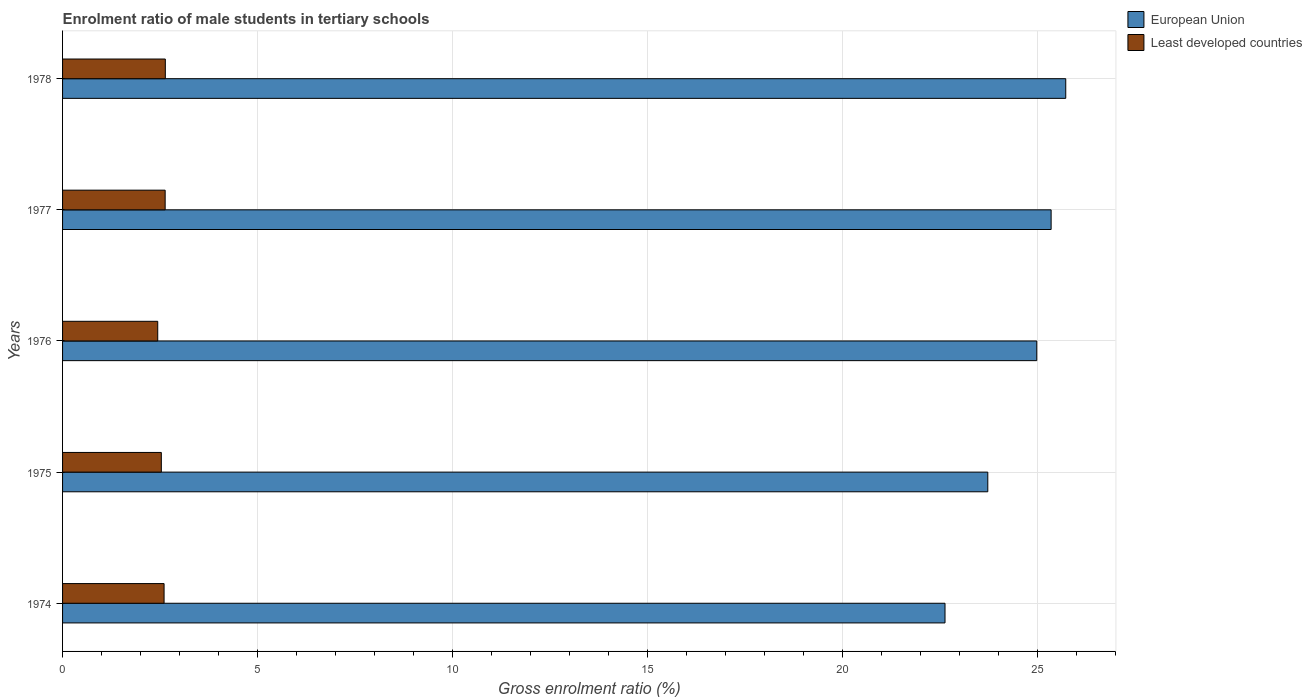How many different coloured bars are there?
Your answer should be very brief. 2. How many groups of bars are there?
Your answer should be very brief. 5. Are the number of bars on each tick of the Y-axis equal?
Make the answer very short. Yes. How many bars are there on the 1st tick from the bottom?
Your answer should be compact. 2. What is the label of the 3rd group of bars from the top?
Your answer should be compact. 1976. In how many cases, is the number of bars for a given year not equal to the number of legend labels?
Offer a terse response. 0. What is the enrolment ratio of male students in tertiary schools in Least developed countries in 1978?
Give a very brief answer. 2.63. Across all years, what is the maximum enrolment ratio of male students in tertiary schools in European Union?
Your answer should be compact. 25.72. Across all years, what is the minimum enrolment ratio of male students in tertiary schools in European Union?
Provide a succinct answer. 22.63. In which year was the enrolment ratio of male students in tertiary schools in Least developed countries maximum?
Your answer should be compact. 1978. In which year was the enrolment ratio of male students in tertiary schools in European Union minimum?
Keep it short and to the point. 1974. What is the total enrolment ratio of male students in tertiary schools in European Union in the graph?
Your answer should be compact. 122.4. What is the difference between the enrolment ratio of male students in tertiary schools in Least developed countries in 1977 and that in 1978?
Provide a short and direct response. -0. What is the difference between the enrolment ratio of male students in tertiary schools in European Union in 1975 and the enrolment ratio of male students in tertiary schools in Least developed countries in 1974?
Make the answer very short. 21.12. What is the average enrolment ratio of male students in tertiary schools in European Union per year?
Ensure brevity in your answer.  24.48. In the year 1978, what is the difference between the enrolment ratio of male students in tertiary schools in European Union and enrolment ratio of male students in tertiary schools in Least developed countries?
Your answer should be very brief. 23.09. What is the ratio of the enrolment ratio of male students in tertiary schools in European Union in 1974 to that in 1978?
Ensure brevity in your answer.  0.88. Is the enrolment ratio of male students in tertiary schools in Least developed countries in 1977 less than that in 1978?
Offer a terse response. Yes. What is the difference between the highest and the second highest enrolment ratio of male students in tertiary schools in Least developed countries?
Ensure brevity in your answer.  0. What is the difference between the highest and the lowest enrolment ratio of male students in tertiary schools in Least developed countries?
Your response must be concise. 0.19. What does the 2nd bar from the bottom in 1974 represents?
Keep it short and to the point. Least developed countries. Are all the bars in the graph horizontal?
Provide a succinct answer. Yes. Are the values on the major ticks of X-axis written in scientific E-notation?
Provide a succinct answer. No. Does the graph contain any zero values?
Ensure brevity in your answer.  No. Where does the legend appear in the graph?
Make the answer very short. Top right. How are the legend labels stacked?
Your answer should be compact. Vertical. What is the title of the graph?
Offer a terse response. Enrolment ratio of male students in tertiary schools. Does "Dominican Republic" appear as one of the legend labels in the graph?
Your response must be concise. No. What is the label or title of the X-axis?
Make the answer very short. Gross enrolment ratio (%). What is the label or title of the Y-axis?
Give a very brief answer. Years. What is the Gross enrolment ratio (%) in European Union in 1974?
Your response must be concise. 22.63. What is the Gross enrolment ratio (%) in Least developed countries in 1974?
Offer a terse response. 2.6. What is the Gross enrolment ratio (%) in European Union in 1975?
Ensure brevity in your answer.  23.72. What is the Gross enrolment ratio (%) of Least developed countries in 1975?
Keep it short and to the point. 2.53. What is the Gross enrolment ratio (%) in European Union in 1976?
Your response must be concise. 24.98. What is the Gross enrolment ratio (%) of Least developed countries in 1976?
Provide a short and direct response. 2.44. What is the Gross enrolment ratio (%) of European Union in 1977?
Ensure brevity in your answer.  25.35. What is the Gross enrolment ratio (%) in Least developed countries in 1977?
Your response must be concise. 2.63. What is the Gross enrolment ratio (%) of European Union in 1978?
Your answer should be compact. 25.72. What is the Gross enrolment ratio (%) in Least developed countries in 1978?
Keep it short and to the point. 2.63. Across all years, what is the maximum Gross enrolment ratio (%) in European Union?
Offer a very short reply. 25.72. Across all years, what is the maximum Gross enrolment ratio (%) of Least developed countries?
Your answer should be compact. 2.63. Across all years, what is the minimum Gross enrolment ratio (%) of European Union?
Your response must be concise. 22.63. Across all years, what is the minimum Gross enrolment ratio (%) of Least developed countries?
Offer a terse response. 2.44. What is the total Gross enrolment ratio (%) of European Union in the graph?
Ensure brevity in your answer.  122.4. What is the total Gross enrolment ratio (%) in Least developed countries in the graph?
Offer a terse response. 12.84. What is the difference between the Gross enrolment ratio (%) of European Union in 1974 and that in 1975?
Offer a very short reply. -1.1. What is the difference between the Gross enrolment ratio (%) in Least developed countries in 1974 and that in 1975?
Your answer should be compact. 0.07. What is the difference between the Gross enrolment ratio (%) of European Union in 1974 and that in 1976?
Your answer should be compact. -2.35. What is the difference between the Gross enrolment ratio (%) of Least developed countries in 1974 and that in 1976?
Make the answer very short. 0.16. What is the difference between the Gross enrolment ratio (%) in European Union in 1974 and that in 1977?
Your answer should be compact. -2.72. What is the difference between the Gross enrolment ratio (%) in Least developed countries in 1974 and that in 1977?
Offer a terse response. -0.03. What is the difference between the Gross enrolment ratio (%) of European Union in 1974 and that in 1978?
Provide a short and direct response. -3.1. What is the difference between the Gross enrolment ratio (%) of Least developed countries in 1974 and that in 1978?
Provide a short and direct response. -0.03. What is the difference between the Gross enrolment ratio (%) of European Union in 1975 and that in 1976?
Your answer should be very brief. -1.26. What is the difference between the Gross enrolment ratio (%) in Least developed countries in 1975 and that in 1976?
Your answer should be very brief. 0.09. What is the difference between the Gross enrolment ratio (%) in European Union in 1975 and that in 1977?
Ensure brevity in your answer.  -1.62. What is the difference between the Gross enrolment ratio (%) of Least developed countries in 1975 and that in 1977?
Make the answer very short. -0.1. What is the difference between the Gross enrolment ratio (%) of European Union in 1975 and that in 1978?
Your answer should be compact. -2. What is the difference between the Gross enrolment ratio (%) of Least developed countries in 1975 and that in 1978?
Provide a succinct answer. -0.1. What is the difference between the Gross enrolment ratio (%) of European Union in 1976 and that in 1977?
Give a very brief answer. -0.37. What is the difference between the Gross enrolment ratio (%) in Least developed countries in 1976 and that in 1977?
Your response must be concise. -0.19. What is the difference between the Gross enrolment ratio (%) of European Union in 1976 and that in 1978?
Give a very brief answer. -0.74. What is the difference between the Gross enrolment ratio (%) in Least developed countries in 1976 and that in 1978?
Provide a short and direct response. -0.19. What is the difference between the Gross enrolment ratio (%) in European Union in 1977 and that in 1978?
Offer a terse response. -0.38. What is the difference between the Gross enrolment ratio (%) in Least developed countries in 1977 and that in 1978?
Offer a terse response. -0. What is the difference between the Gross enrolment ratio (%) of European Union in 1974 and the Gross enrolment ratio (%) of Least developed countries in 1975?
Provide a short and direct response. 20.09. What is the difference between the Gross enrolment ratio (%) in European Union in 1974 and the Gross enrolment ratio (%) in Least developed countries in 1976?
Your answer should be compact. 20.19. What is the difference between the Gross enrolment ratio (%) in European Union in 1974 and the Gross enrolment ratio (%) in Least developed countries in 1977?
Keep it short and to the point. 20. What is the difference between the Gross enrolment ratio (%) of European Union in 1974 and the Gross enrolment ratio (%) of Least developed countries in 1978?
Offer a very short reply. 19.99. What is the difference between the Gross enrolment ratio (%) of European Union in 1975 and the Gross enrolment ratio (%) of Least developed countries in 1976?
Give a very brief answer. 21.28. What is the difference between the Gross enrolment ratio (%) of European Union in 1975 and the Gross enrolment ratio (%) of Least developed countries in 1977?
Give a very brief answer. 21.09. What is the difference between the Gross enrolment ratio (%) of European Union in 1975 and the Gross enrolment ratio (%) of Least developed countries in 1978?
Your answer should be very brief. 21.09. What is the difference between the Gross enrolment ratio (%) in European Union in 1976 and the Gross enrolment ratio (%) in Least developed countries in 1977?
Your response must be concise. 22.35. What is the difference between the Gross enrolment ratio (%) of European Union in 1976 and the Gross enrolment ratio (%) of Least developed countries in 1978?
Ensure brevity in your answer.  22.34. What is the difference between the Gross enrolment ratio (%) in European Union in 1977 and the Gross enrolment ratio (%) in Least developed countries in 1978?
Provide a short and direct response. 22.71. What is the average Gross enrolment ratio (%) in European Union per year?
Your answer should be compact. 24.48. What is the average Gross enrolment ratio (%) of Least developed countries per year?
Provide a succinct answer. 2.57. In the year 1974, what is the difference between the Gross enrolment ratio (%) in European Union and Gross enrolment ratio (%) in Least developed countries?
Provide a short and direct response. 20.02. In the year 1975, what is the difference between the Gross enrolment ratio (%) in European Union and Gross enrolment ratio (%) in Least developed countries?
Offer a very short reply. 21.19. In the year 1976, what is the difference between the Gross enrolment ratio (%) in European Union and Gross enrolment ratio (%) in Least developed countries?
Offer a very short reply. 22.54. In the year 1977, what is the difference between the Gross enrolment ratio (%) in European Union and Gross enrolment ratio (%) in Least developed countries?
Your answer should be compact. 22.72. In the year 1978, what is the difference between the Gross enrolment ratio (%) in European Union and Gross enrolment ratio (%) in Least developed countries?
Your answer should be very brief. 23.09. What is the ratio of the Gross enrolment ratio (%) in European Union in 1974 to that in 1975?
Keep it short and to the point. 0.95. What is the ratio of the Gross enrolment ratio (%) in Least developed countries in 1974 to that in 1975?
Provide a short and direct response. 1.03. What is the ratio of the Gross enrolment ratio (%) of European Union in 1974 to that in 1976?
Offer a very short reply. 0.91. What is the ratio of the Gross enrolment ratio (%) in Least developed countries in 1974 to that in 1976?
Ensure brevity in your answer.  1.07. What is the ratio of the Gross enrolment ratio (%) of European Union in 1974 to that in 1977?
Offer a very short reply. 0.89. What is the ratio of the Gross enrolment ratio (%) in European Union in 1974 to that in 1978?
Ensure brevity in your answer.  0.88. What is the ratio of the Gross enrolment ratio (%) in Least developed countries in 1974 to that in 1978?
Give a very brief answer. 0.99. What is the ratio of the Gross enrolment ratio (%) in European Union in 1975 to that in 1976?
Provide a short and direct response. 0.95. What is the ratio of the Gross enrolment ratio (%) of Least developed countries in 1975 to that in 1976?
Ensure brevity in your answer.  1.04. What is the ratio of the Gross enrolment ratio (%) of European Union in 1975 to that in 1977?
Offer a terse response. 0.94. What is the ratio of the Gross enrolment ratio (%) of Least developed countries in 1975 to that in 1977?
Your answer should be very brief. 0.96. What is the ratio of the Gross enrolment ratio (%) in European Union in 1975 to that in 1978?
Keep it short and to the point. 0.92. What is the ratio of the Gross enrolment ratio (%) in Least developed countries in 1975 to that in 1978?
Your answer should be compact. 0.96. What is the ratio of the Gross enrolment ratio (%) of European Union in 1976 to that in 1977?
Keep it short and to the point. 0.99. What is the ratio of the Gross enrolment ratio (%) in Least developed countries in 1976 to that in 1977?
Give a very brief answer. 0.93. What is the ratio of the Gross enrolment ratio (%) of European Union in 1976 to that in 1978?
Make the answer very short. 0.97. What is the ratio of the Gross enrolment ratio (%) in Least developed countries in 1976 to that in 1978?
Your response must be concise. 0.93. What is the ratio of the Gross enrolment ratio (%) in European Union in 1977 to that in 1978?
Make the answer very short. 0.99. What is the ratio of the Gross enrolment ratio (%) in Least developed countries in 1977 to that in 1978?
Your answer should be very brief. 1. What is the difference between the highest and the second highest Gross enrolment ratio (%) in European Union?
Give a very brief answer. 0.38. What is the difference between the highest and the second highest Gross enrolment ratio (%) in Least developed countries?
Provide a succinct answer. 0. What is the difference between the highest and the lowest Gross enrolment ratio (%) of European Union?
Provide a succinct answer. 3.1. What is the difference between the highest and the lowest Gross enrolment ratio (%) of Least developed countries?
Ensure brevity in your answer.  0.19. 